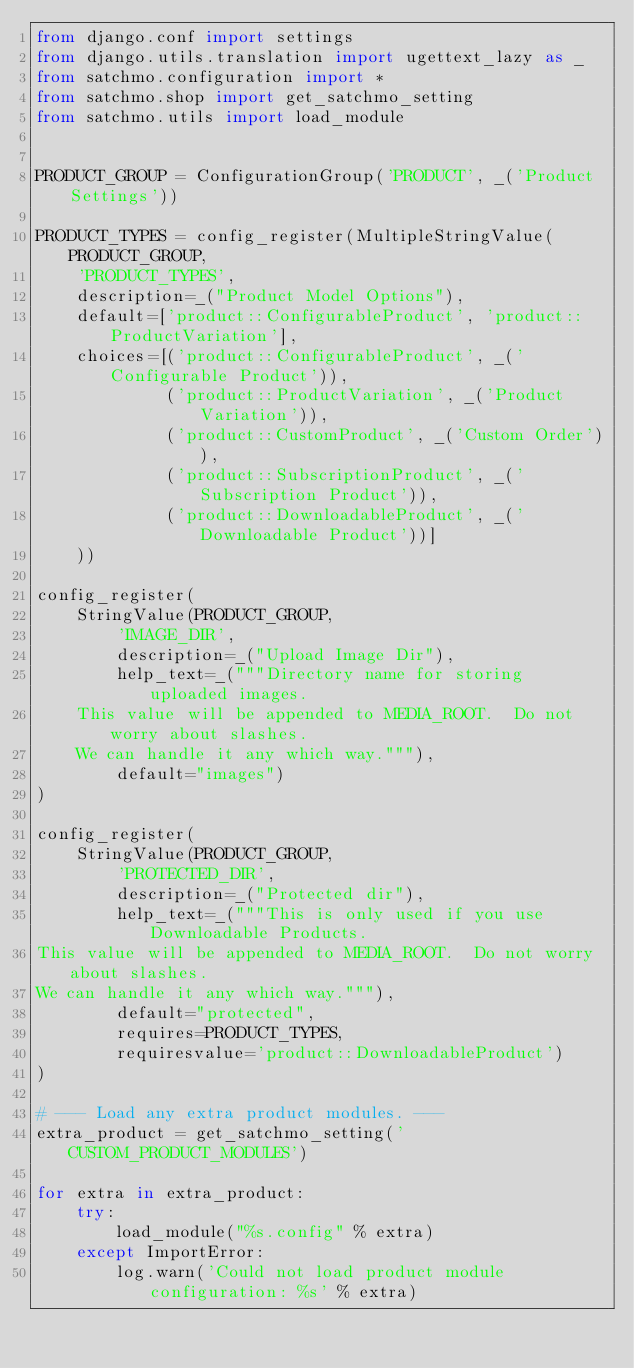Convert code to text. <code><loc_0><loc_0><loc_500><loc_500><_Python_>from django.conf import settings
from django.utils.translation import ugettext_lazy as _
from satchmo.configuration import *
from satchmo.shop import get_satchmo_setting
from satchmo.utils import load_module


PRODUCT_GROUP = ConfigurationGroup('PRODUCT', _('Product Settings'))

PRODUCT_TYPES = config_register(MultipleStringValue(PRODUCT_GROUP,
    'PRODUCT_TYPES',
    description=_("Product Model Options"),
    default=['product::ConfigurableProduct', 'product::ProductVariation'],
    choices=[('product::ConfigurableProduct', _('Configurable Product')),
             ('product::ProductVariation', _('Product Variation')),
             ('product::CustomProduct', _('Custom Order')),
             ('product::SubscriptionProduct', _('Subscription Product')),
             ('product::DownloadableProduct', _('Downloadable Product'))]
    ))

config_register(
    StringValue(PRODUCT_GROUP,
        'IMAGE_DIR',
        description=_("Upload Image Dir"),
        help_text=_("""Directory name for storing uploaded images.
    This value will be appended to MEDIA_ROOT.  Do not worry about slashes.
    We can handle it any which way."""),
        default="images")
)

config_register(
    StringValue(PRODUCT_GROUP,
        'PROTECTED_DIR',
        description=_("Protected dir"),
        help_text=_("""This is only used if you use Downloadable Products.
This value will be appended to MEDIA_ROOT.  Do not worry about slashes.
We can handle it any which way."""),
        default="protected",
        requires=PRODUCT_TYPES,
        requiresvalue='product::DownloadableProduct')
)

# --- Load any extra product modules. ---
extra_product = get_satchmo_setting('CUSTOM_PRODUCT_MODULES')

for extra in extra_product:
    try:
        load_module("%s.config" % extra)
    except ImportError:
        log.warn('Could not load product module configuration: %s' % extra)
</code> 